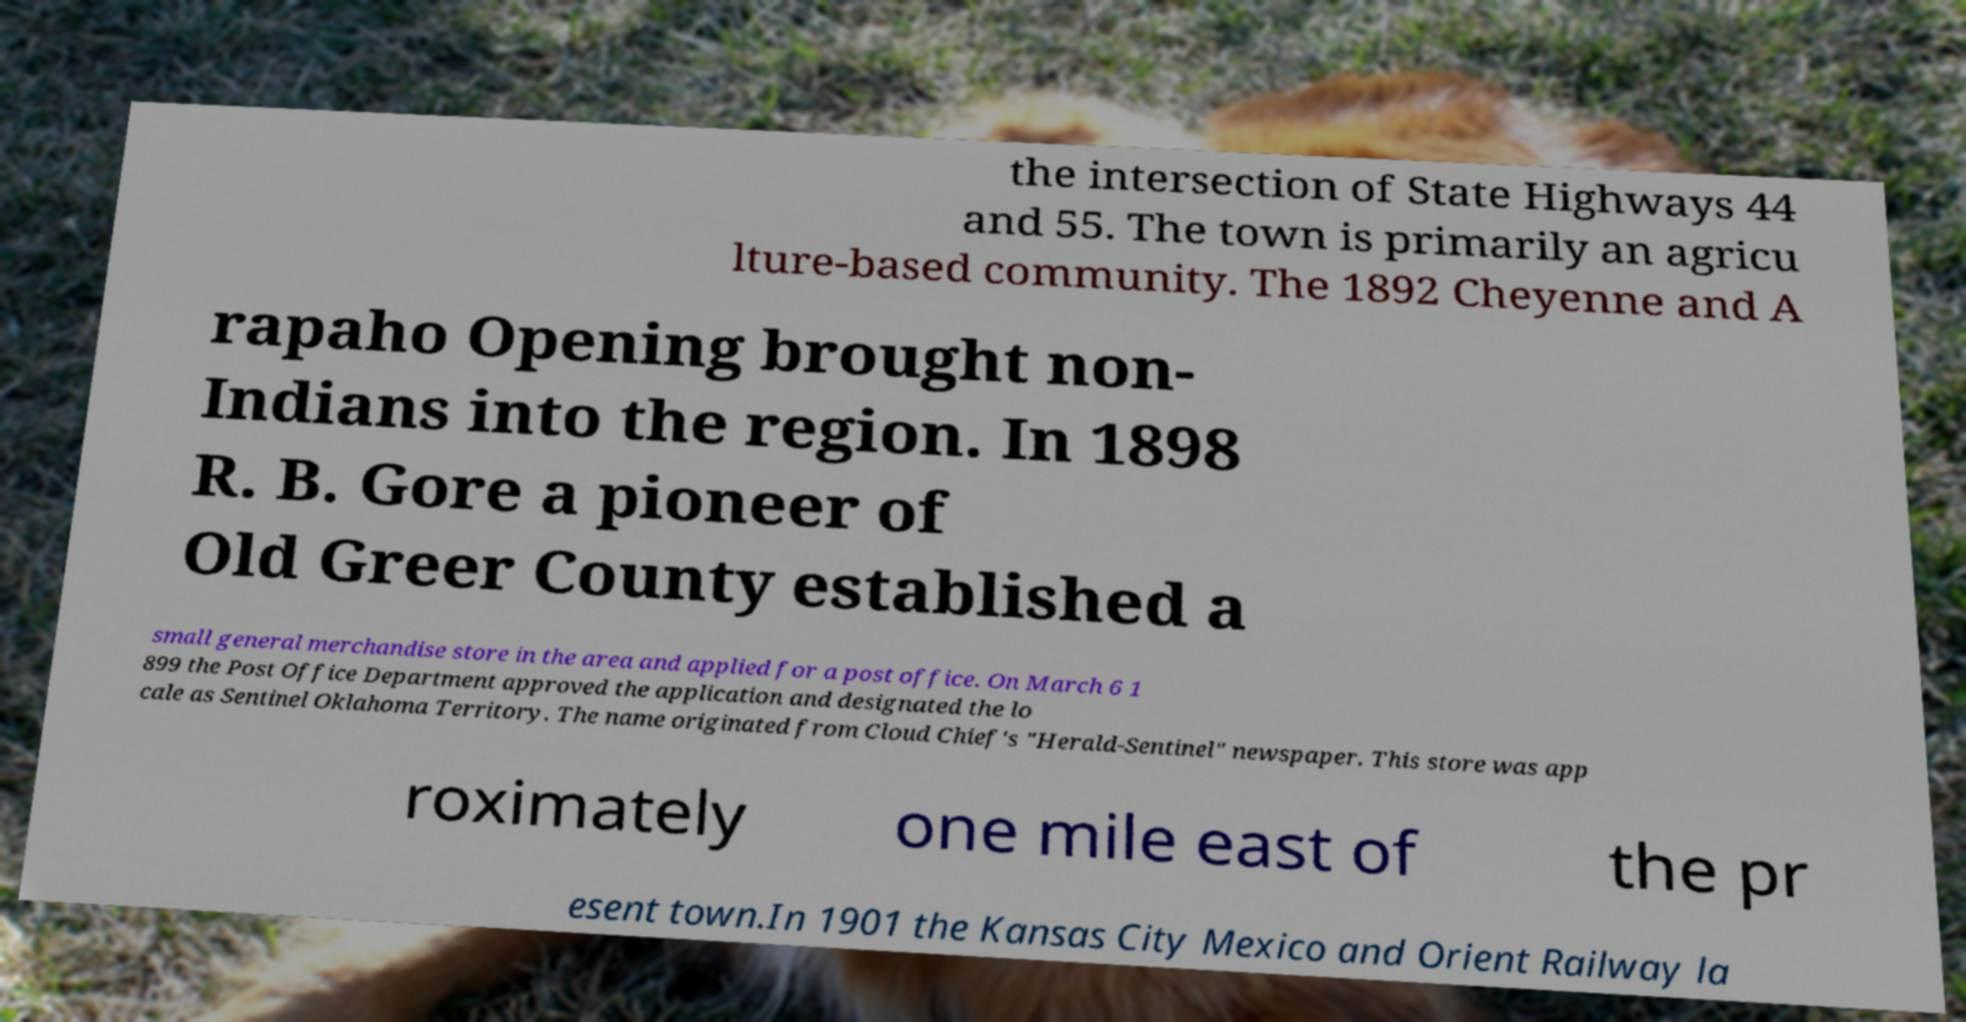Please identify and transcribe the text found in this image. the intersection of State Highways 44 and 55. The town is primarily an agricu lture-based community. The 1892 Cheyenne and A rapaho Opening brought non- Indians into the region. In 1898 R. B. Gore a pioneer of Old Greer County established a small general merchandise store in the area and applied for a post office. On March 6 1 899 the Post Office Department approved the application and designated the lo cale as Sentinel Oklahoma Territory. The name originated from Cloud Chief's "Herald-Sentinel" newspaper. This store was app roximately one mile east of the pr esent town.In 1901 the Kansas City Mexico and Orient Railway la 